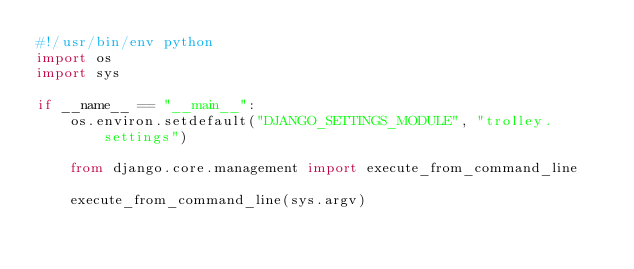Convert code to text. <code><loc_0><loc_0><loc_500><loc_500><_Python_>#!/usr/bin/env python
import os
import sys

if __name__ == "__main__":
    os.environ.setdefault("DJANGO_SETTINGS_MODULE", "trolley.settings")

    from django.core.management import execute_from_command_line

    execute_from_command_line(sys.argv)
</code> 